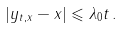<formula> <loc_0><loc_0><loc_500><loc_500>| y _ { t , x } - x | \leqslant \lambda _ { 0 } t \, .</formula> 